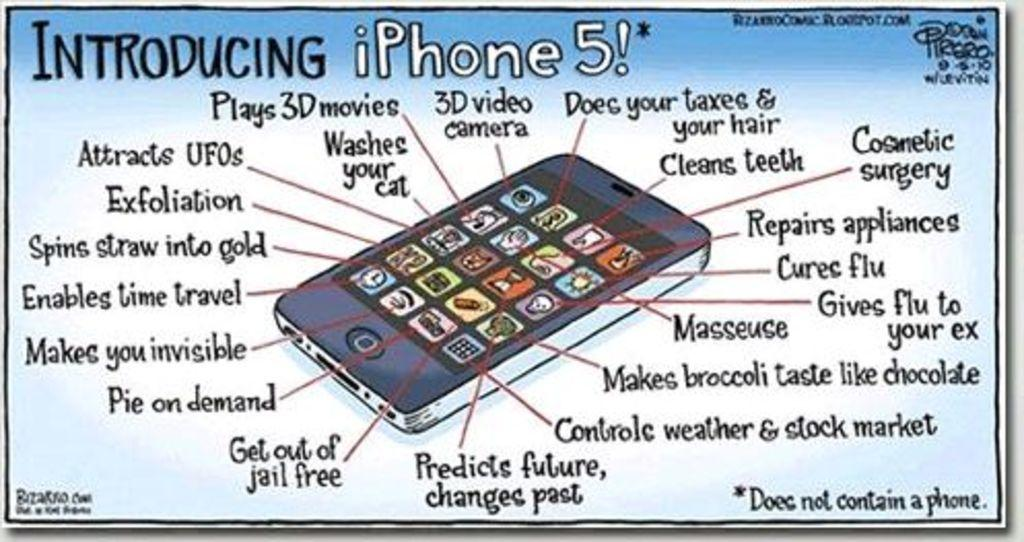<image>
Present a compact description of the photo's key features. A cartoon titled Introducing iPhone 5 with imagined features highlighted. 